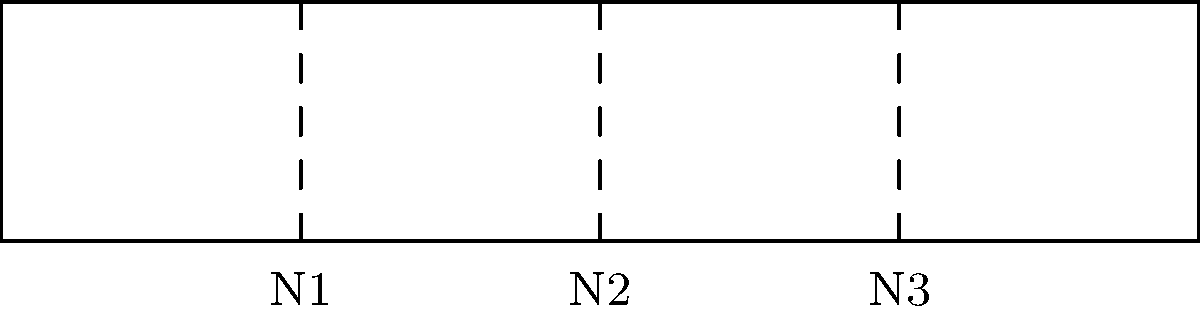In a tin whistle with a cylindrical bore of length L, as shown in the diagram, what is the relationship between the wavelength ($\lambda$) of the third harmonic and the length of the bore? To understand the relationship between the wavelength of the third harmonic and the length of the bore in a tin whistle, let's follow these steps:

1. In a cylindrical bore open at both ends (like in a tin whistle), the fundamental frequency (first harmonic) has antinodes at both ends and a node in the middle.

2. The length of the bore (L) is equal to half the wavelength of the fundamental frequency:
   $$L = \frac{\lambda_1}{2}$$

3. For higher harmonics, the relationship between the harmonic number (n) and the wavelength ($\lambda_n$) is:
   $$L = n \cdot \frac{\lambda_n}{2}$$

4. In this case, we're interested in the third harmonic (n = 3). Substituting this into the equation:
   $$L = 3 \cdot \frac{\lambda_3}{2}$$

5. Rearranging this equation to solve for $\lambda_3$:
   $$\lambda_3 = \frac{2L}{3}$$

This final equation shows the relationship between the wavelength of the third harmonic and the length of the bore.
Answer: $\lambda_3 = \frac{2L}{3}$ 